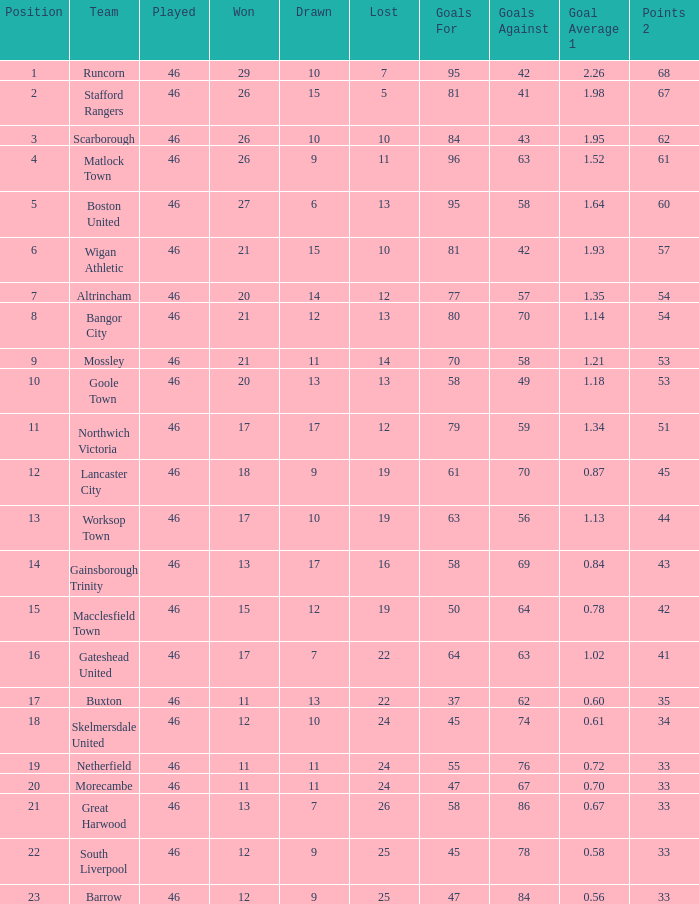What has been the greatest position reached by the bangor city team? 8.0. 